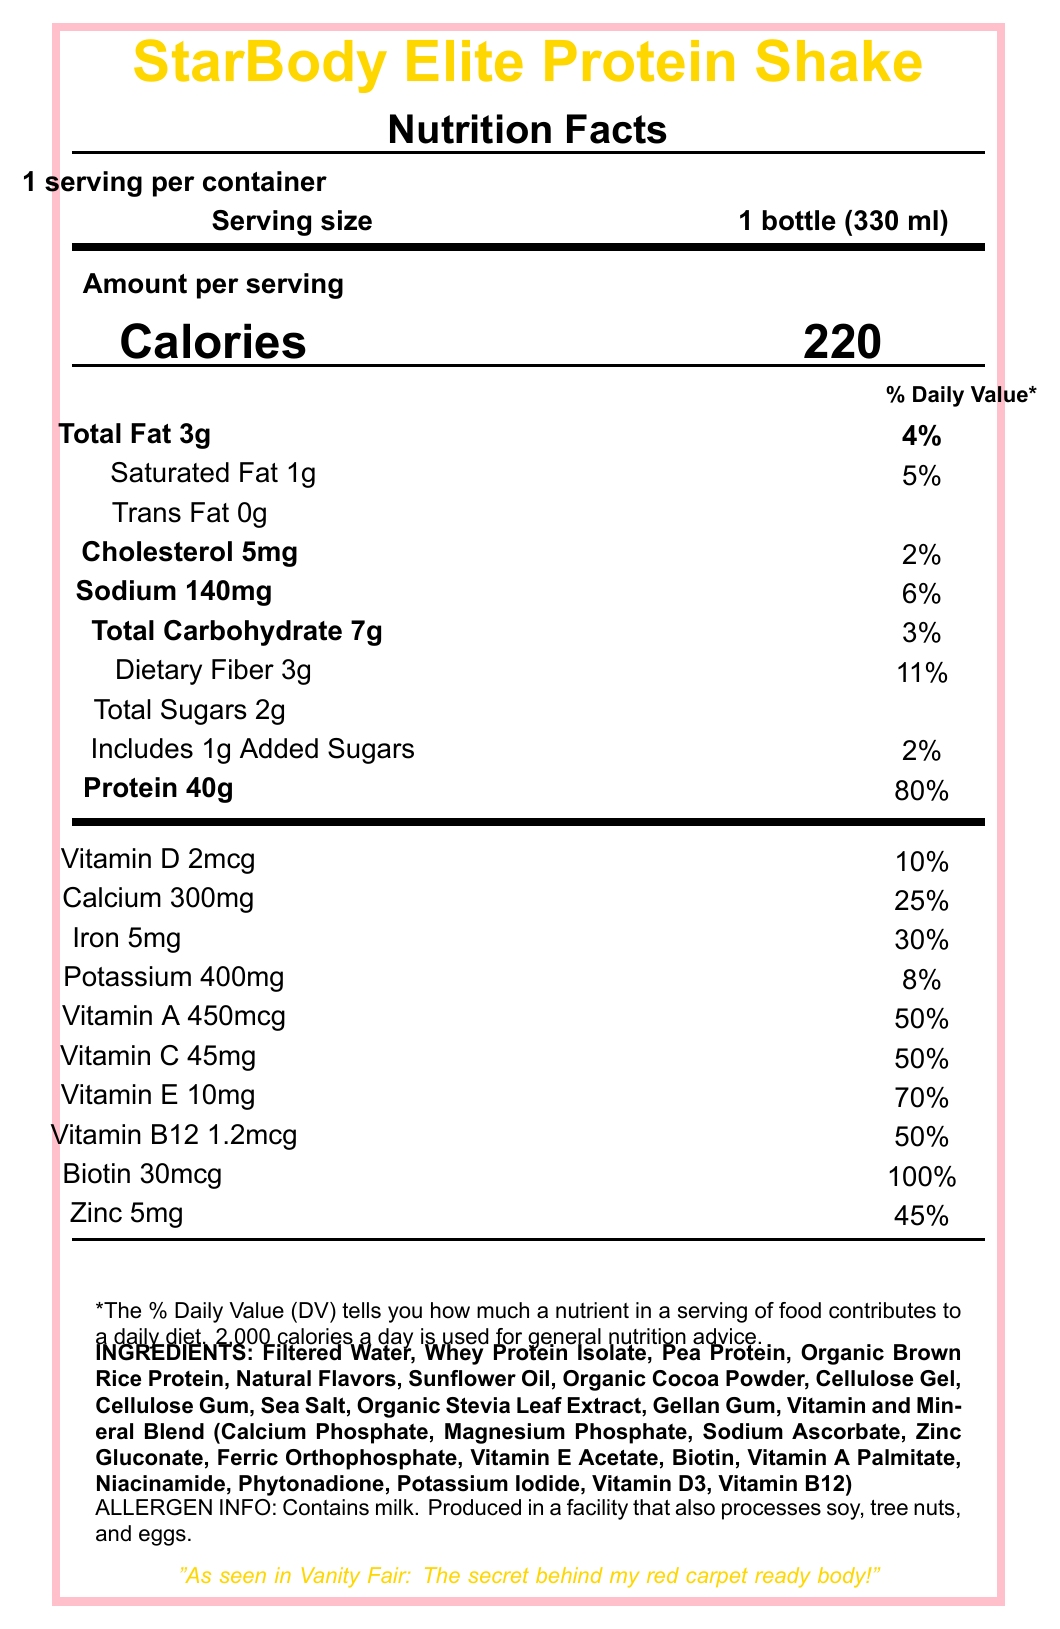what is the calories per serving of StarBody Elite Protein Shake? The document lists the calorie count as "Calories 220" in the "Amount per serving" section.
Answer: 220 what is the serving size for the StarBody Elite Protein Shake? The serving size is mentioned as "1 bottle (330 ml)" in the "Serving size" section of the document.
Answer: 1 bottle (330 ml) how many grams of protein are in one serving? The protein amount is specified as "Protein 40g" under the nutrition facts.
Answer: 40g how much Vitamin A is included in percentage of Daily Value? The amount of Vitamin A is listed as 450mcg, which corresponds to 50% of the Daily Value.
Answer: 50% does StarBody Elite Protein Shake contain any trans fat? The document clearly states "Trans Fat 0g" indicating there is no trans fat in the shake.
Answer: No what are the first three ingredients listed on the StarBody Elite Protein Shake? The ingredients are listed in descending order of quantity, with the first three being Filtered Water, Whey Protein Isolate, and Pea Protein.
Answer: Filtered Water, Whey Protein Isolate, Pea Protein which nutrient offers the highest percentage of Daily Value? A. Calcium B. Iron C. Protein D. Biotin The Biotin amount is 30mcg, which is 100% of the Daily Value, making it the highest percentage listed.
Answer: D. Biotin how many grams of total sugars does the shake contain? A. 0g B. 2g C. 5g D. 7g The document shows "Total Sugars 2g" under the nutrition facts.
Answer: B. 2g is the product non-GMO? The quality statement in the document mentions the product is made with premium, non-GMO ingredients.
Answer: Yes how long should the product be consumed after opening? The usage instructions specify that the shake should be "Consume[d] within 24 hours of opening."
Answer: Within 24 hours how does the document describe the StarBody Elite Protein Shake? The document provides comprehensive information including nutrition facts, ingredients, allergen information, endorsements, quality statements, and usage instructions, which collectively describe the product.
Answer: The StarBody Elite Protein Shake is presented as a high-protein, specially formulated meal replacement shake that boasts premium, non-GMO ingredients. It supports physique maintenance, providing a significant amount of protein, essential vitamins, and minerals without artificial colors, flavors, or preservatives. what is the amount of dietary fiber present? The dietary fiber content is listed as "Dietary Fiber 3g" under the nutrition facts.
Answer: 3g which nutrient has the least Daily Value percentage? A. Protein B. Sodium C. Cholesterol D. Total Carbohydrate Cholesterol has the least Daily Value percentage at 2%, as specified in the nutrition facts.
Answer: C. Cholesterol is the product intended to diagnose, treat, cure, or prevent any disease? The disclaimer states that "This product is not intended to diagnose, treat, cure, or prevent any disease."
Answer: No what are the allergens contained in the product? The allergen information specifies milk as an ingredient and notes potential cross-contamination with soy, tree nuts, and eggs.
Answer: Contains milk. Produced in a facility that also processes soy, tree nuts, and eggs. what is the main source of protein in the StarBody Elite Protein Shake? The document lists multiple protein sources such as Whey Protein Isolate, Pea Protein, and Organic Brown Rice Protein, but it does not specify which is the main source.
Answer: Cannot be determined 